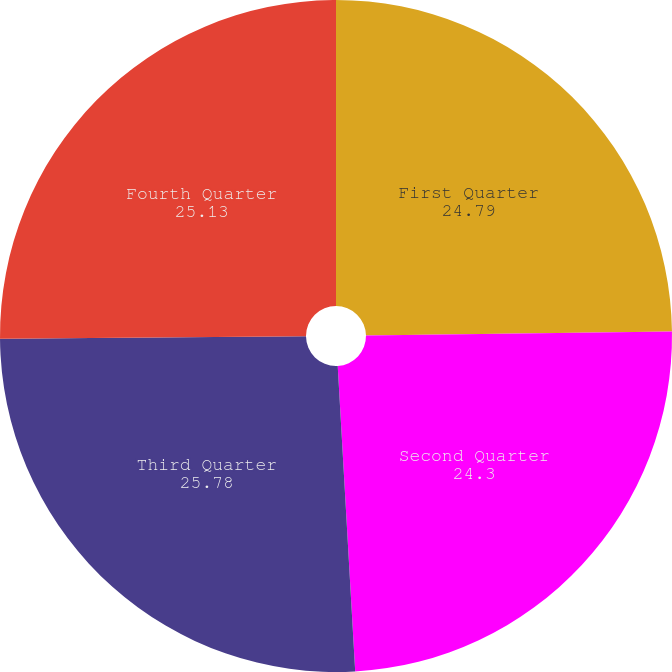<chart> <loc_0><loc_0><loc_500><loc_500><pie_chart><fcel>First Quarter<fcel>Second Quarter<fcel>Third Quarter<fcel>Fourth Quarter<nl><fcel>24.79%<fcel>24.3%<fcel>25.78%<fcel>25.13%<nl></chart> 